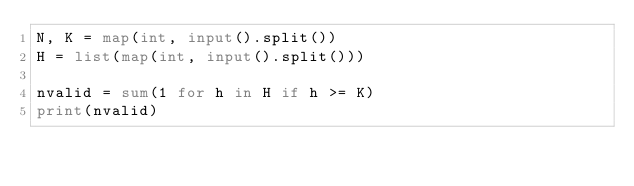Convert code to text. <code><loc_0><loc_0><loc_500><loc_500><_Python_>N, K = map(int, input().split())
H = list(map(int, input().split()))

nvalid = sum(1 for h in H if h >= K)
print(nvalid)</code> 